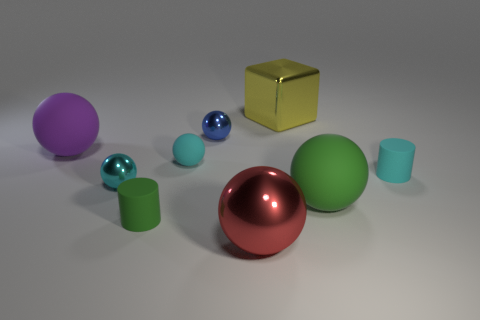How many cyan balls must be subtracted to get 1 cyan balls? 1 Subtract all tiny blue metal balls. How many balls are left? 5 Subtract all cyan cylinders. How many cylinders are left? 1 Subtract all cylinders. How many objects are left? 7 Subtract 1 cylinders. How many cylinders are left? 1 Add 5 small red matte things. How many small red matte things exist? 5 Subtract 1 green balls. How many objects are left? 8 Subtract all brown balls. Subtract all gray cylinders. How many balls are left? 6 Subtract all brown balls. How many purple blocks are left? 0 Subtract all purple rubber spheres. Subtract all tiny green cylinders. How many objects are left? 7 